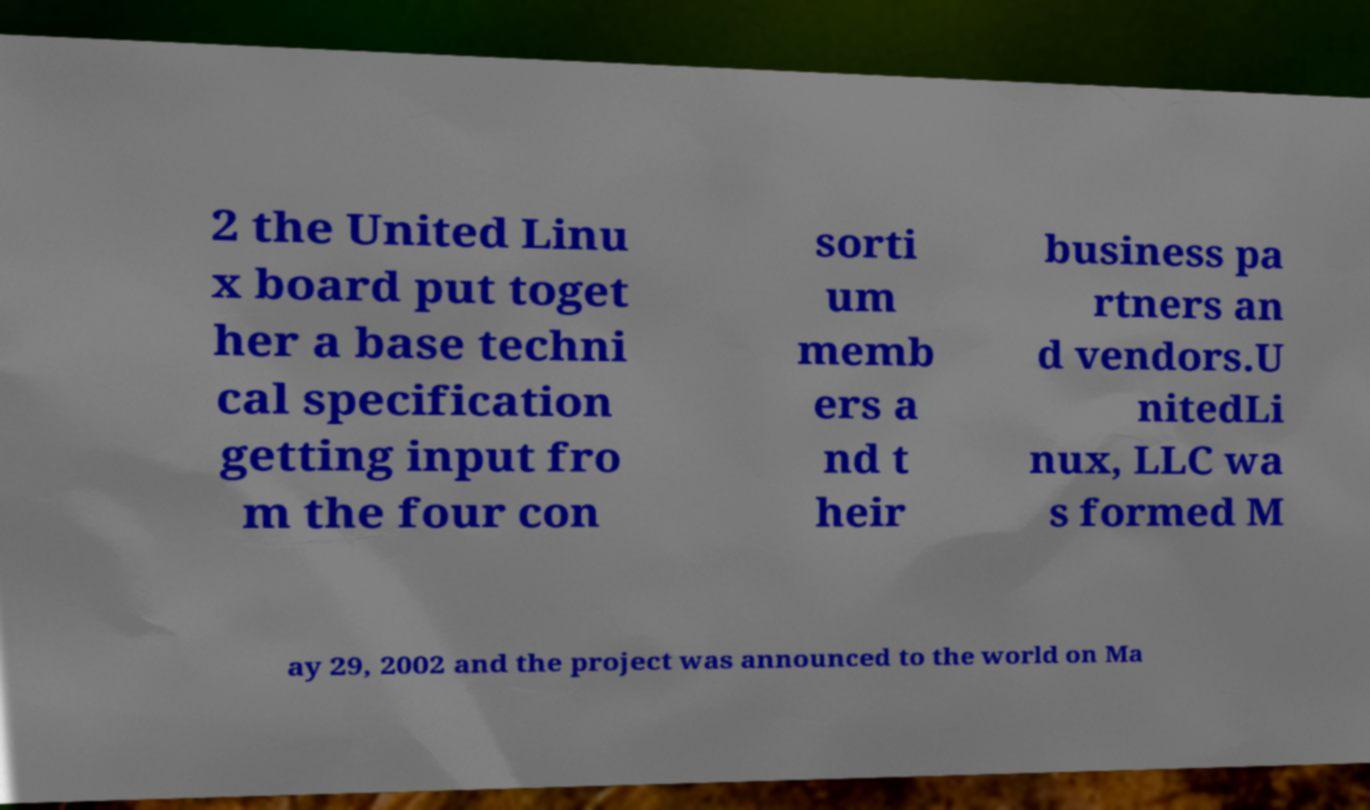Can you accurately transcribe the text from the provided image for me? 2 the United Linu x board put toget her a base techni cal specification getting input fro m the four con sorti um memb ers a nd t heir business pa rtners an d vendors.U nitedLi nux, LLC wa s formed M ay 29, 2002 and the project was announced to the world on Ma 